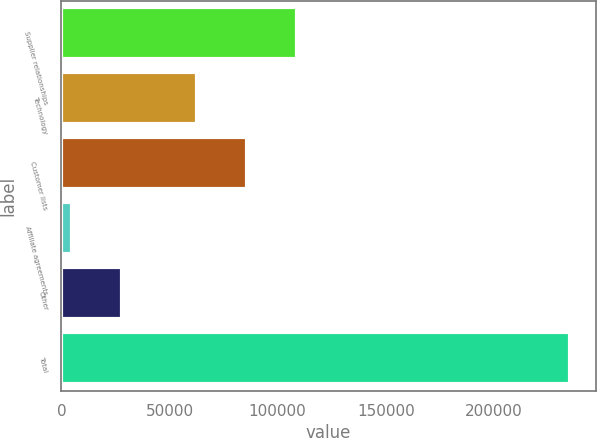<chart> <loc_0><loc_0><loc_500><loc_500><bar_chart><fcel>Supplier relationships<fcel>Technology<fcel>Customer lists<fcel>Affiliate agreements<fcel>Other<fcel>Total<nl><fcel>108982<fcel>62892<fcel>85937.2<fcel>4901<fcel>27946.2<fcel>235353<nl></chart> 